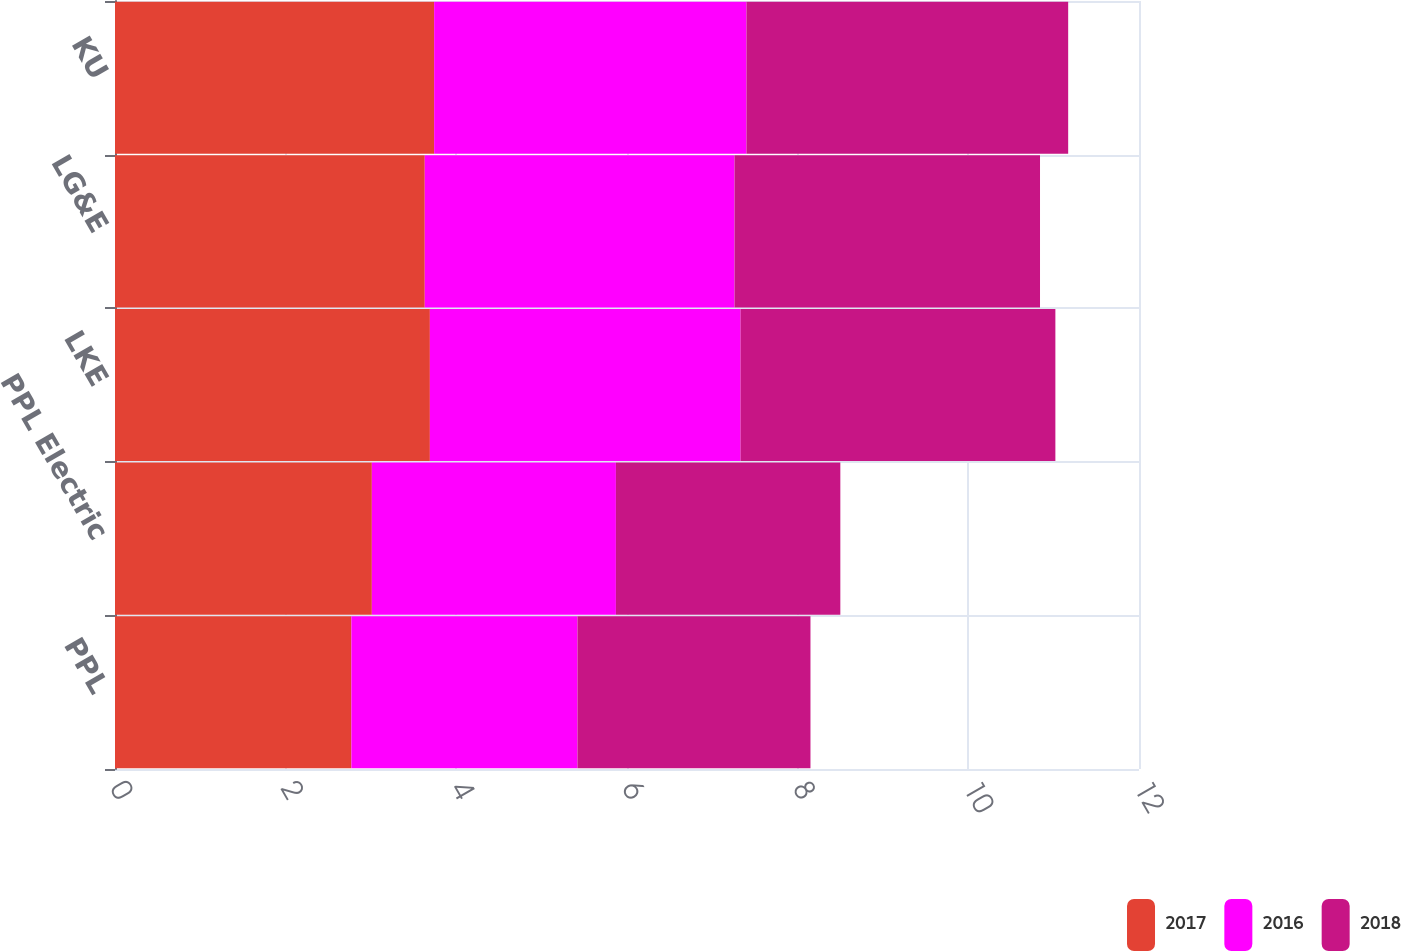Convert chart to OTSL. <chart><loc_0><loc_0><loc_500><loc_500><stacked_bar_chart><ecel><fcel>PPL<fcel>PPL Electric<fcel>LKE<fcel>LG&E<fcel>KU<nl><fcel>2017<fcel>2.77<fcel>3.01<fcel>3.69<fcel>3.63<fcel>3.74<nl><fcel>2016<fcel>2.65<fcel>2.86<fcel>3.64<fcel>3.63<fcel>3.66<nl><fcel>2018<fcel>2.73<fcel>2.63<fcel>3.69<fcel>3.58<fcel>3.77<nl></chart> 